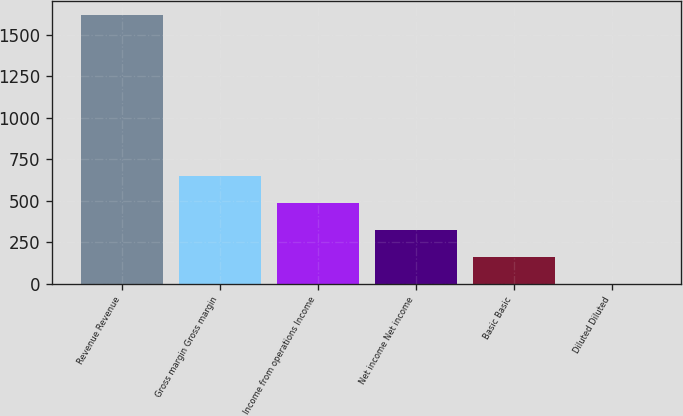<chart> <loc_0><loc_0><loc_500><loc_500><bar_chart><fcel>Revenue Revenue<fcel>Gross margin Gross margin<fcel>Income from operations Income<fcel>Net income Net income<fcel>Basic Basic<fcel>Diluted Diluted<nl><fcel>1620<fcel>648.21<fcel>486.25<fcel>324.29<fcel>162.33<fcel>0.37<nl></chart> 